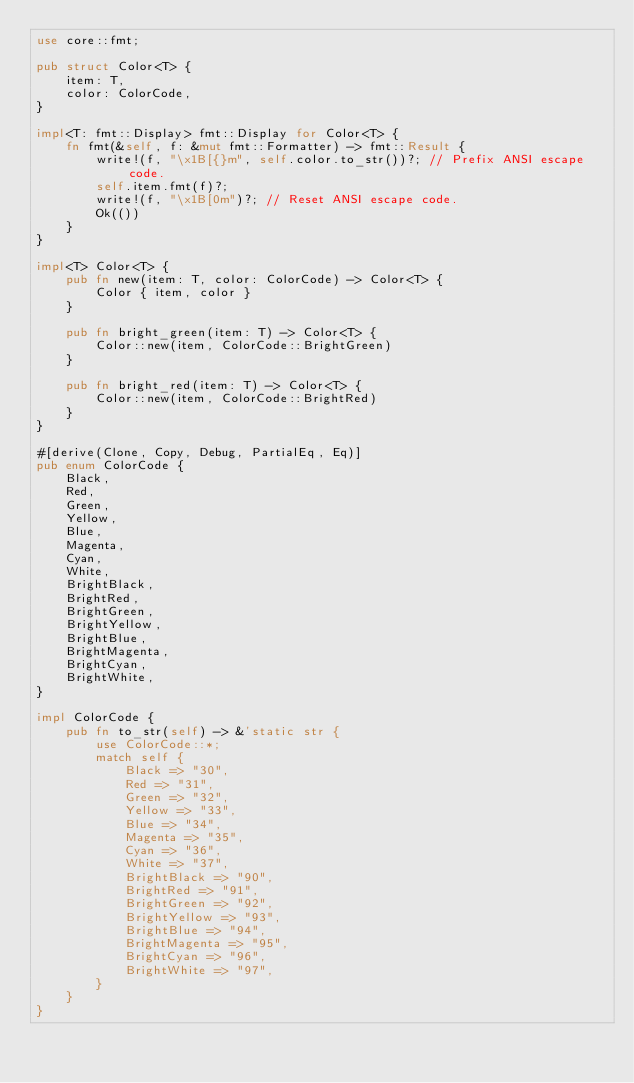<code> <loc_0><loc_0><loc_500><loc_500><_Rust_>use core::fmt;

pub struct Color<T> {
    item: T,
    color: ColorCode,
}

impl<T: fmt::Display> fmt::Display for Color<T> {
    fn fmt(&self, f: &mut fmt::Formatter) -> fmt::Result {
        write!(f, "\x1B[{}m", self.color.to_str())?; // Prefix ANSI escape code.
        self.item.fmt(f)?;
        write!(f, "\x1B[0m")?; // Reset ANSI escape code.
        Ok(())
    }
}

impl<T> Color<T> {
    pub fn new(item: T, color: ColorCode) -> Color<T> {
        Color { item, color }
    }

    pub fn bright_green(item: T) -> Color<T> {
        Color::new(item, ColorCode::BrightGreen)
    }

    pub fn bright_red(item: T) -> Color<T> {
        Color::new(item, ColorCode::BrightRed)
    }
}

#[derive(Clone, Copy, Debug, PartialEq, Eq)]
pub enum ColorCode {
    Black,
    Red,
    Green,
    Yellow,
    Blue,
    Magenta,
    Cyan,
    White,
    BrightBlack,
    BrightRed,
    BrightGreen,
    BrightYellow,
    BrightBlue,
    BrightMagenta,
    BrightCyan,
    BrightWhite,
}

impl ColorCode {
    pub fn to_str(self) -> &'static str {
        use ColorCode::*;
        match self {
            Black => "30",
            Red => "31",
            Green => "32",
            Yellow => "33",
            Blue => "34",
            Magenta => "35",
            Cyan => "36",
            White => "37",
            BrightBlack => "90",
            BrightRed => "91",
            BrightGreen => "92",
            BrightYellow => "93",
            BrightBlue => "94",
            BrightMagenta => "95",
            BrightCyan => "96",
            BrightWhite => "97",
        }
    }
}
</code> 